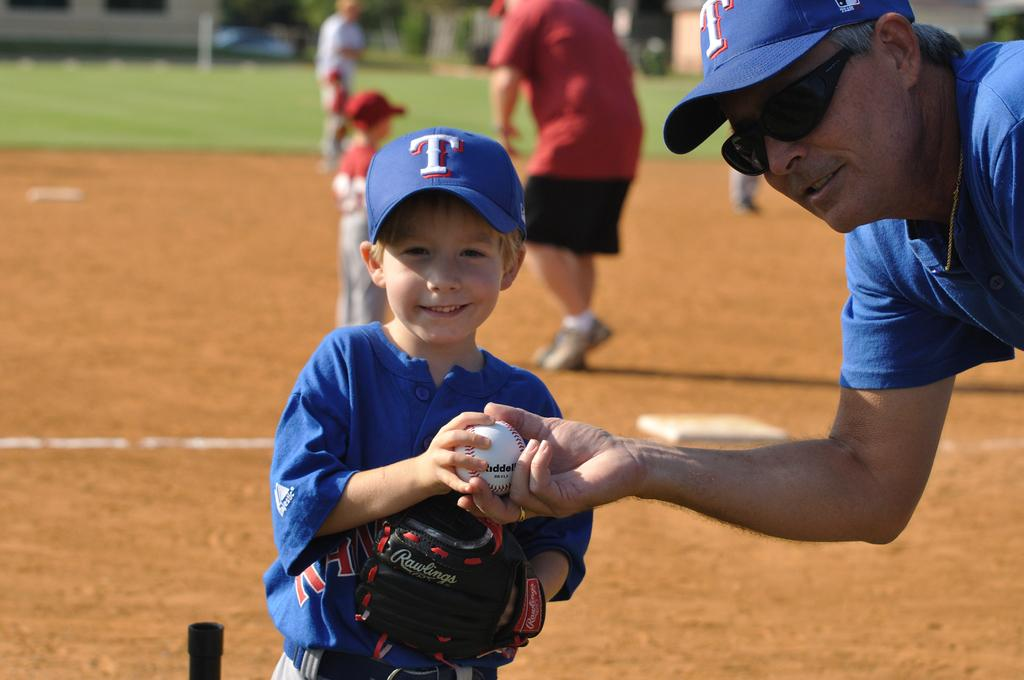<image>
Summarize the visual content of the image. A man wearing a hat with a T on it hands a ball to a small boy wearing a hat with a T on it. 